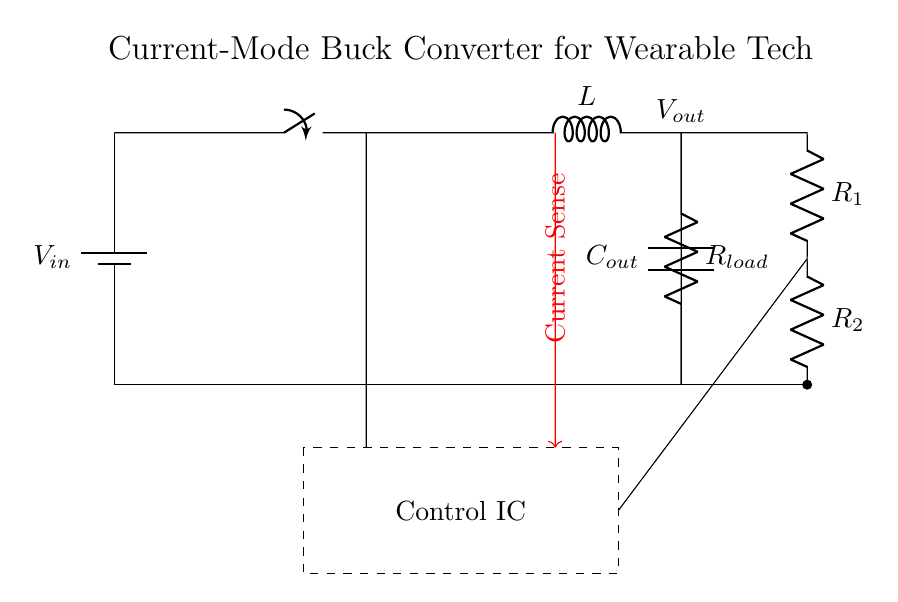What is the input voltage of the circuit? The input voltage is represented by the battery symbol labeled V_in at the top of the circuit diagram. The diagram does not specify a numerical value, but it indicates the source voltage for the circuit.
Answer: V_in What is the purpose of the inductor in this circuit? The inductor labeled L is crucial for energy storage and control of the output voltage in a buck converter. It helps in smoothing out the current and maintaining a steady voltage when switching occurs.
Answer: Energy storage How many resistors are present in the feedback loop? There are two resistors in the feedback loop, labeled R1 and R2, which are connected to provide voltage feedback for regulation. Counting the components in that section confirms the two resistors.
Answer: Two What component is used for current sensing in this circuit? The current sensing is done using the red arrow leading away from the inductor labeled with "Current Sense." This indicates that the circuit is using a method to sense current for feedback control.
Answer: Current Sense Which component regulates the output voltage in this circuit? The control integrated circuit (IC) located in the dashed rectangle is responsible for regulating the output voltage by managing the switching action and feedback from the output.
Answer: Control IC What type of converter is depicted in this circuit? The circuit diagram illustrates a current-mode buck converter, which is specifically designed to step down voltage efficiently while managing the current through feedback. The title of the diagram clearly states this.
Answer: Buck converter What is the function of the output capacitor in this design? The capacitor labeled C_out smooths out the output voltage by filtering and reducing voltage ripple when the load varies. This function is essential in providing stable voltage to the load.
Answer: Smooth output voltage 